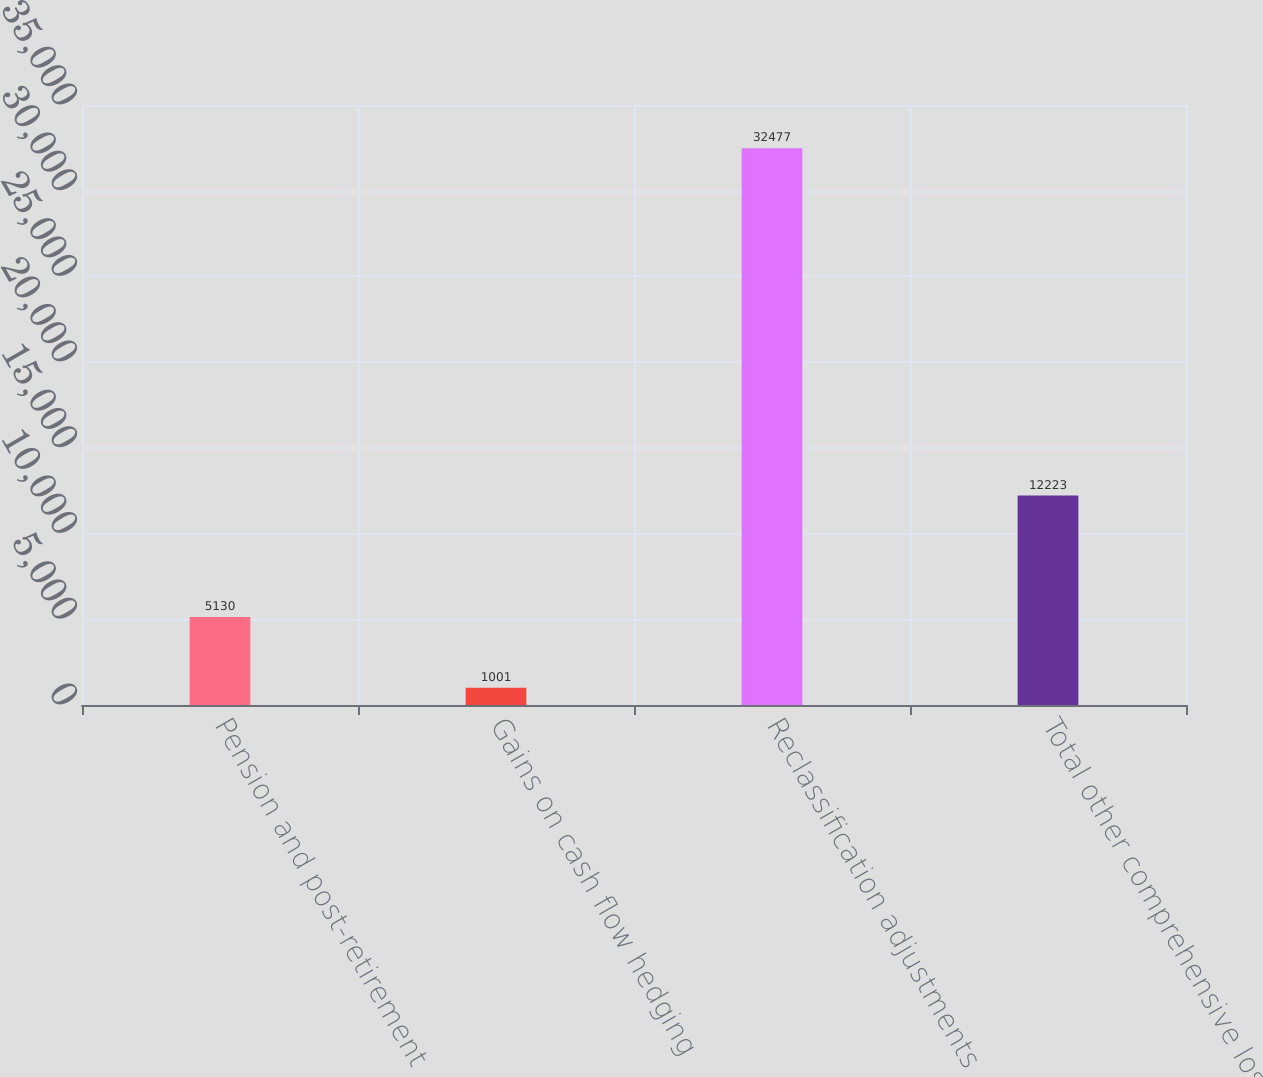<chart> <loc_0><loc_0><loc_500><loc_500><bar_chart><fcel>Pension and post-retirement<fcel>Gains on cash flow hedging<fcel>Reclassification adjustments<fcel>Total other comprehensive loss<nl><fcel>5130<fcel>1001<fcel>32477<fcel>12223<nl></chart> 